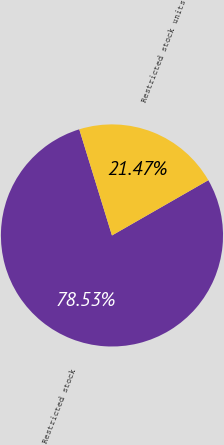Convert chart to OTSL. <chart><loc_0><loc_0><loc_500><loc_500><pie_chart><fcel>Restricted stock<fcel>Restricted stock units<nl><fcel>78.53%<fcel>21.47%<nl></chart> 